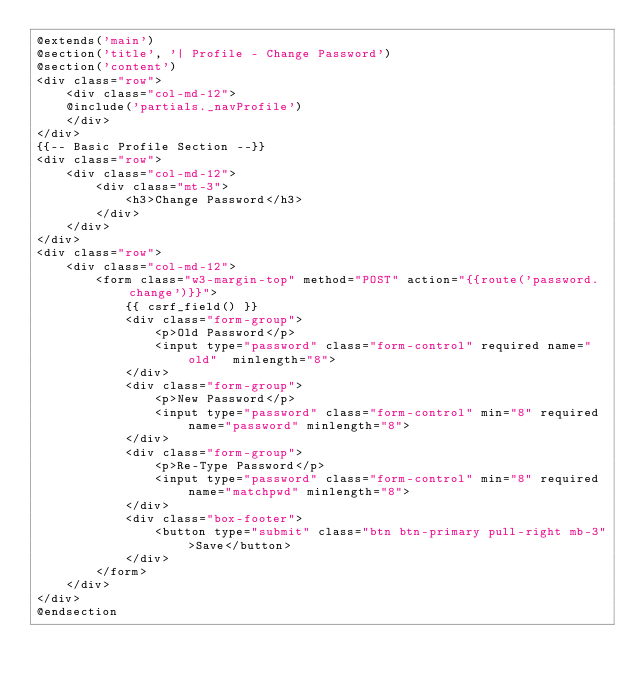Convert code to text. <code><loc_0><loc_0><loc_500><loc_500><_PHP_>@extends('main') 
@section('title', '| Profile - Change Password') 
@section('content')
<div class="row">
    <div class="col-md-12">
    @include('partials._navProfile')
    </div>
</div>
{{-- Basic Profile Section --}}
<div class="row">
    <div class="col-md-12">
        <div class="mt-3">
            <h3>Change Password</h3>
        </div>
    </div>
</div>
<div class="row">
    <div class="col-md-12">
        <form class="w3-margin-top" method="POST" action="{{route('password.change')}}">
            {{ csrf_field() }}
            <div class="form-group">
                <p>Old Password</p>
                <input type="password" class="form-control" required name="old"  minlength="8">
            </div>
            <div class="form-group">
                <p>New Password</p>
                <input type="password" class="form-control" min="8" required name="password" minlength="8">
            </div>
            <div class="form-group">
                <p>Re-Type Password</p>
                <input type="password" class="form-control" min="8" required name="matchpwd" minlength="8">
            </div>
            <div class="box-footer">
                <button type="submit" class="btn btn-primary pull-right mb-3">Save</button>
            </div>
        </form>
    </div>
</div>
@endsection</code> 